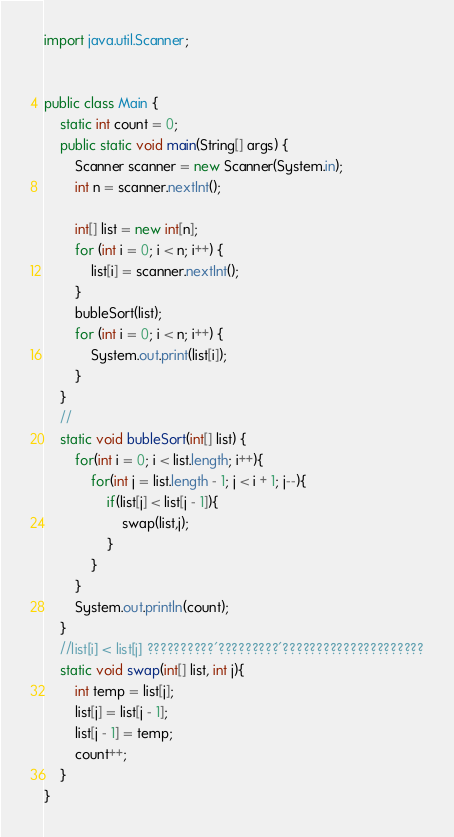Convert code to text. <code><loc_0><loc_0><loc_500><loc_500><_Java_>import java.util.Scanner;


public class Main {
	static int count = 0;
	public static void main(String[] args) {
		Scanner scanner = new Scanner(System.in);
		int n = scanner.nextInt();

		int[] list = new int[n];
		for (int i = 0; i < n; i++) {
			list[i] = scanner.nextInt();
		}
		bubleSort(list);
		for (int i = 0; i < n; i++) {
			System.out.print(list[i]);
		}
	}
	//
	static void bubleSort(int[] list) {
		for(int i = 0; i < list.length; i++){
			for(int j = list.length - 1; j < i + 1; j--){
				if(list[j] < list[j - 1]){
					swap(list,j);
				}
			}
		}
		System.out.println(count);
	}
	//list[i] < list[j] ??????????´?????????´?????????????????????
	static void swap(int[] list, int j){
		int temp = list[j];
		list[j] = list[j - 1];
		list[j - 1] = temp;
		count++;
 	}
}</code> 